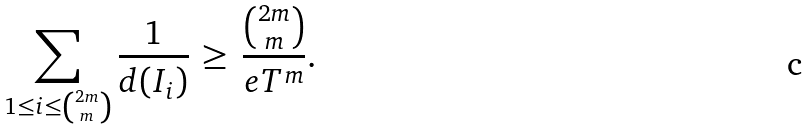<formula> <loc_0><loc_0><loc_500><loc_500>\sum _ { 1 \leq i \leq \binom { 2 m } { m } } \frac { 1 } { d ( I _ { i } ) } \, \geq \, \frac { \binom { 2 m } { m } } { e T ^ { m } } .</formula> 